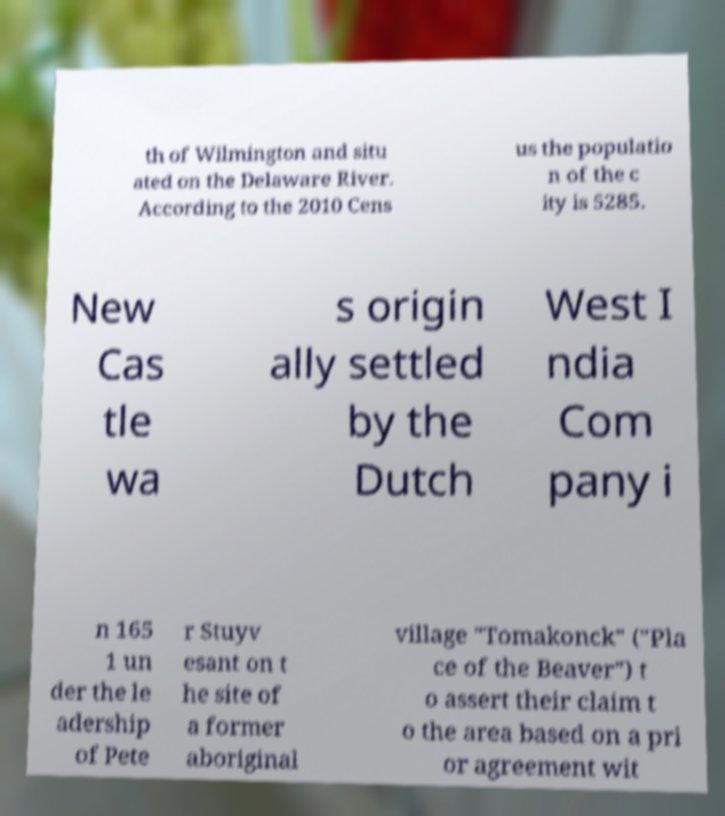I need the written content from this picture converted into text. Can you do that? th of Wilmington and situ ated on the Delaware River. According to the 2010 Cens us the populatio n of the c ity is 5285. New Cas tle wa s origin ally settled by the Dutch West I ndia Com pany i n 165 1 un der the le adership of Pete r Stuyv esant on t he site of a former aboriginal village "Tomakonck" ("Pla ce of the Beaver") t o assert their claim t o the area based on a pri or agreement wit 